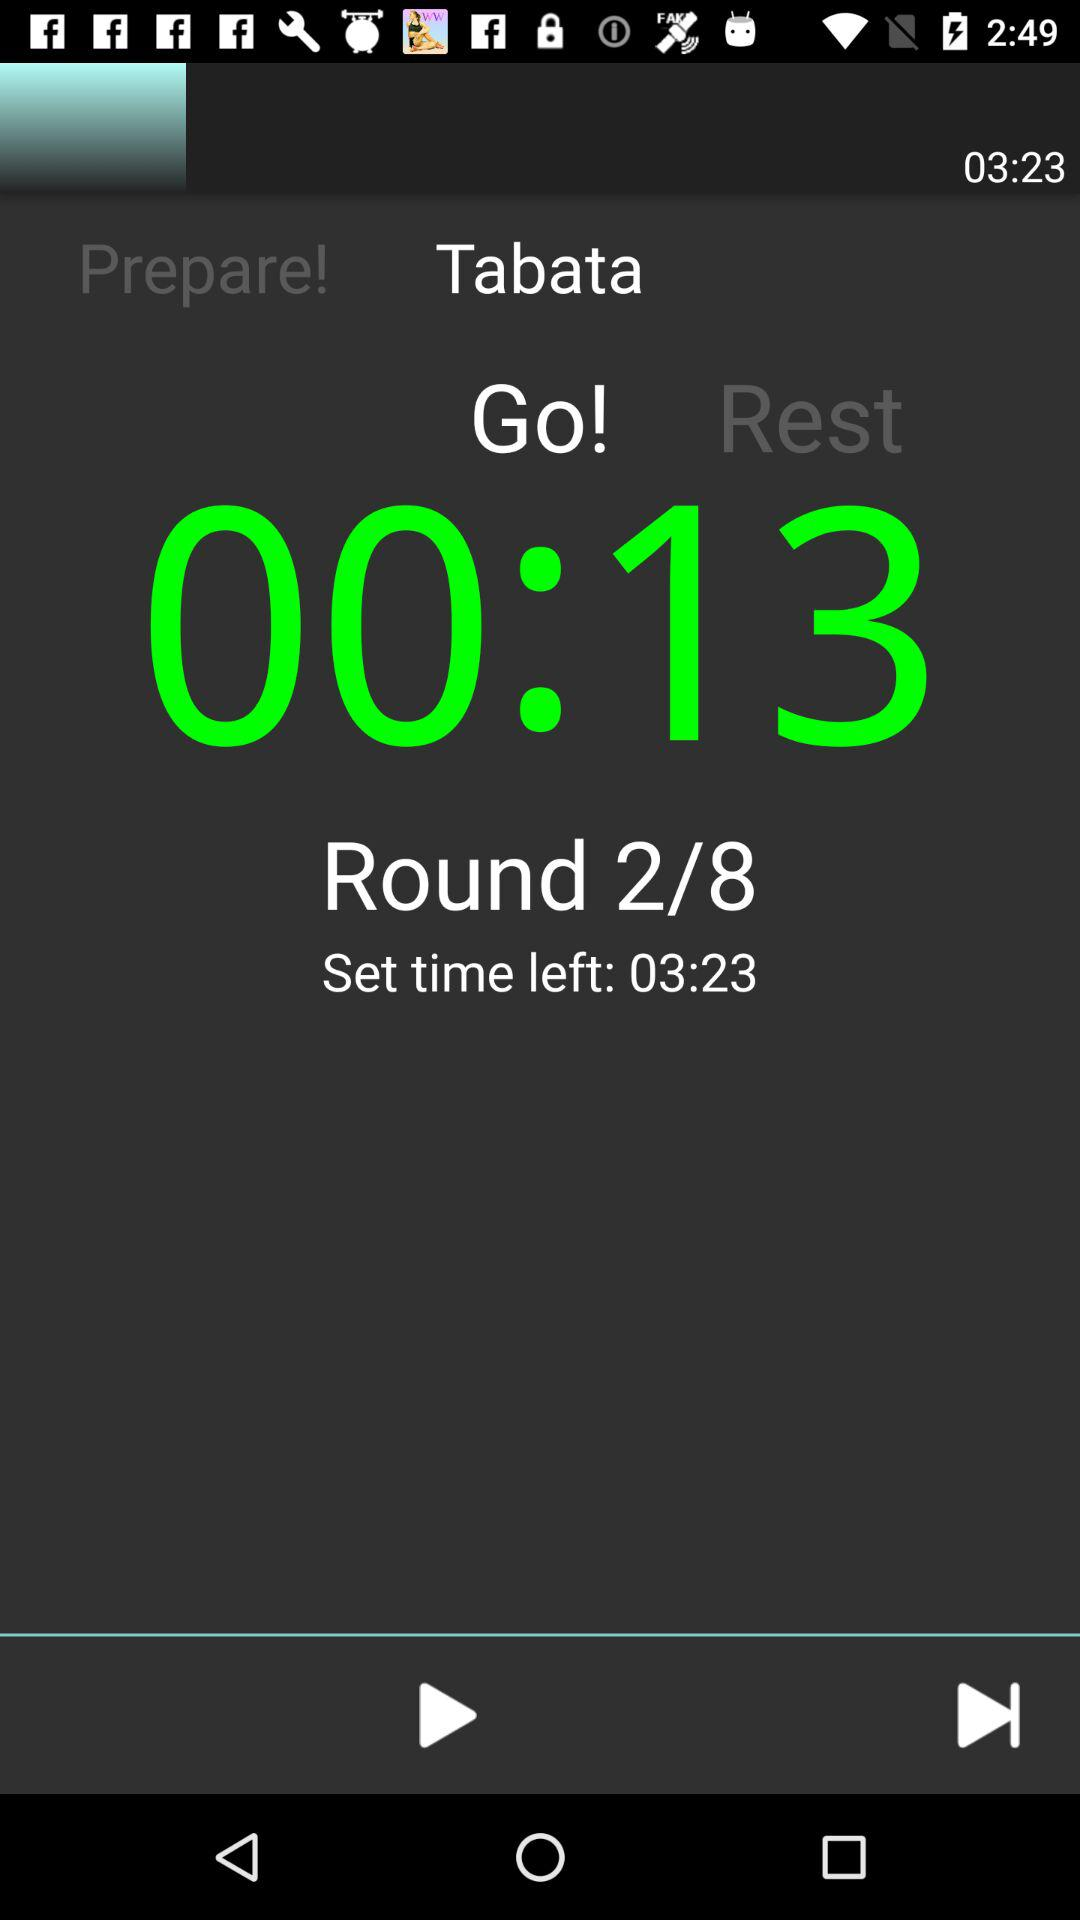How many rounds are left?
Answer the question using a single word or phrase. 6 